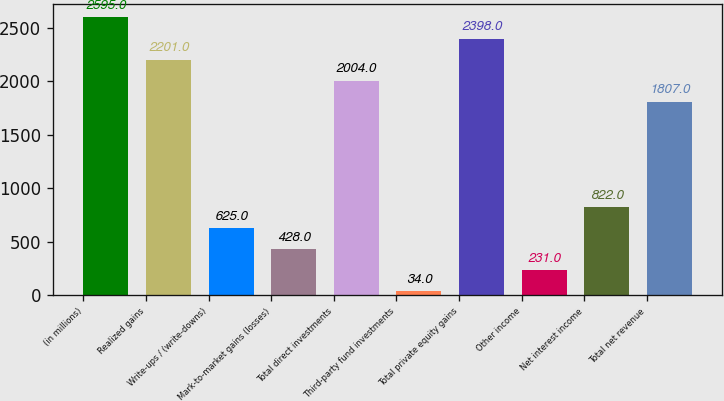Convert chart. <chart><loc_0><loc_0><loc_500><loc_500><bar_chart><fcel>(in millions)<fcel>Realized gains<fcel>Write-ups / (write-downs)<fcel>Mark-to-market gains (losses)<fcel>Total direct investments<fcel>Third-party fund investments<fcel>Total private equity gains<fcel>Other income<fcel>Net interest income<fcel>Total net revenue<nl><fcel>2595<fcel>2201<fcel>625<fcel>428<fcel>2004<fcel>34<fcel>2398<fcel>231<fcel>822<fcel>1807<nl></chart> 